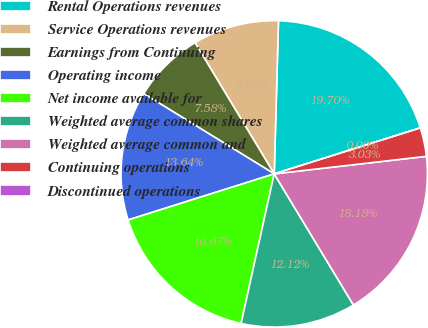Convert chart to OTSL. <chart><loc_0><loc_0><loc_500><loc_500><pie_chart><fcel>Rental Operations revenues<fcel>Service Operations revenues<fcel>Earnings from Continuing<fcel>Operating income<fcel>Net income available for<fcel>Weighted average common shares<fcel>Weighted average common and<fcel>Continuing operations<fcel>Discontinued operations<nl><fcel>19.7%<fcel>9.09%<fcel>7.58%<fcel>13.64%<fcel>16.67%<fcel>12.12%<fcel>18.18%<fcel>3.03%<fcel>0.0%<nl></chart> 